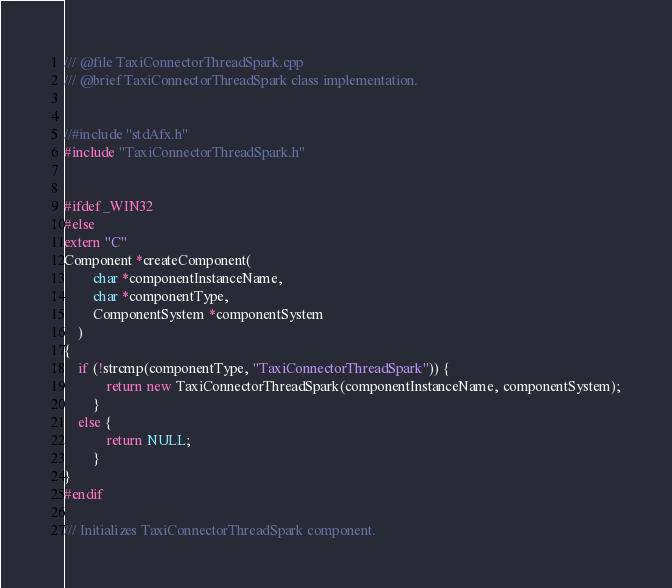<code> <loc_0><loc_0><loc_500><loc_500><_C++_>/// @file TaxiConnectorThreadSpark.cpp
/// @brief TaxiConnectorThreadSpark class implementation.


//#include "stdAfx.h"
#include "TaxiConnectorThreadSpark.h"


#ifdef _WIN32
#else
extern "C"
Component *createComponent(
		char *componentInstanceName,
		char *componentType,
		ComponentSystem *componentSystem
	)
{
	if (!strcmp(componentType, "TaxiConnectorThreadSpark")) {
			return new TaxiConnectorThreadSpark(componentInstanceName, componentSystem);
		}
	else {
			return NULL;
		}
}
#endif

/// Initializes TaxiConnectorThreadSpark component.</code> 